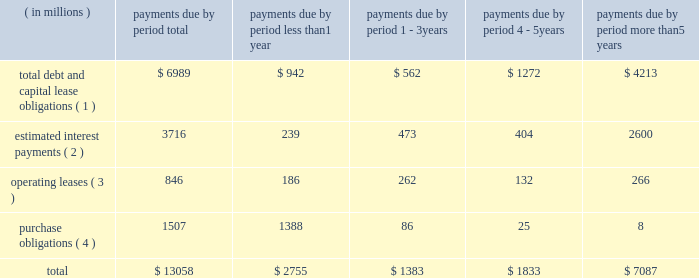Bhge 2018 form 10-k | 41 estimate would equal up to 5% ( 5 % ) of annual revenue .
The expenditures are expected to be used primarily for normal , recurring items necessary to support our business .
We also anticipate making income tax payments in the range of $ 425 million to $ 475 million in 2019 .
Contractual obligations in the table below , we set forth our contractual obligations as of december 31 , 2018 .
Certain amounts included in this table are based on our estimates and assumptions about these obligations , including their duration , anticipated actions by third parties and other factors .
The contractual obligations we will actually pay in future periods may vary from those reflected in the table because the estimates and assumptions are subjective. .
( 1 ) amounts represent the expected cash payments for the principal amounts related to our debt , including capital lease obligations .
Amounts for debt do not include any deferred issuance costs or unamortized discounts or premiums including step up in the value of the debt on the acquisition of baker hughes .
Expected cash payments for interest are excluded from these amounts .
Total debt and capital lease obligations includes $ 896 million payable to ge and its affiliates .
As there is no fixed payment schedule on the amount payable to ge and its affiliates we have classified it as payable in less than one year .
( 2 ) amounts represent the expected cash payments for interest on our long-term debt and capital lease obligations .
( 3 ) amounts represent the future minimum payments under noncancelable operating leases with initial or remaining terms of one year or more .
We enter into operating leases , some of which include renewal options , however , we have excluded renewal options from the table above unless it is anticipated that we will exercise such renewals .
( 4 ) purchase obligations include expenditures for capital assets for 2019 as well as agreements to purchase goods or services that are enforceable and legally binding and that specify all significant terms , including : fixed or minimum quantities to be purchased ; fixed , minimum or variable price provisions ; and the approximate timing of the transaction .
Due to the uncertainty with respect to the timing of potential future cash outflows associated with our uncertain tax positions , we are unable to make reasonable estimates of the period of cash settlement , if any , to the respective taxing authorities .
Therefore , $ 597 million in uncertain tax positions , including interest and penalties , have been excluded from the contractual obligations table above .
See "note 12 .
Income taxes" of the notes to consolidated and combined financial statements in item 8 herein for further information .
We have certain defined benefit pension and other post-retirement benefit plans covering certain of our u.s .
And international employees .
During 2018 , we made contributions and paid direct benefits of approximately $ 72 million in connection with those plans , and we anticipate funding approximately $ 41 million during 2019 .
Amounts for pension funding obligations are based on assumptions that are subject to change , therefore , we are currently not able to reasonably estimate our contribution figures after 2019 .
See "note 11 .
Employee benefit plans" of the notes to consolidated and combined financial statements in item 8 herein for further information .
Off-balance sheet arrangements in the normal course of business with customers , vendors and others , we have entered into off-balance sheet arrangements , such as surety bonds for performance , letters of credit and other bank issued guarantees , which totaled approximately $ 3.6 billion at december 31 , 2018 .
It is not practicable to estimate the fair value of these financial instruments .
None of the off-balance sheet arrangements either has , or is likely to have , a material effect on our consolidated and combined financial statements. .
What portion of the total debt and capital lease obligations is payable to ge and its affiliates? 
Computations: (896 / 6989)
Answer: 0.1282. 